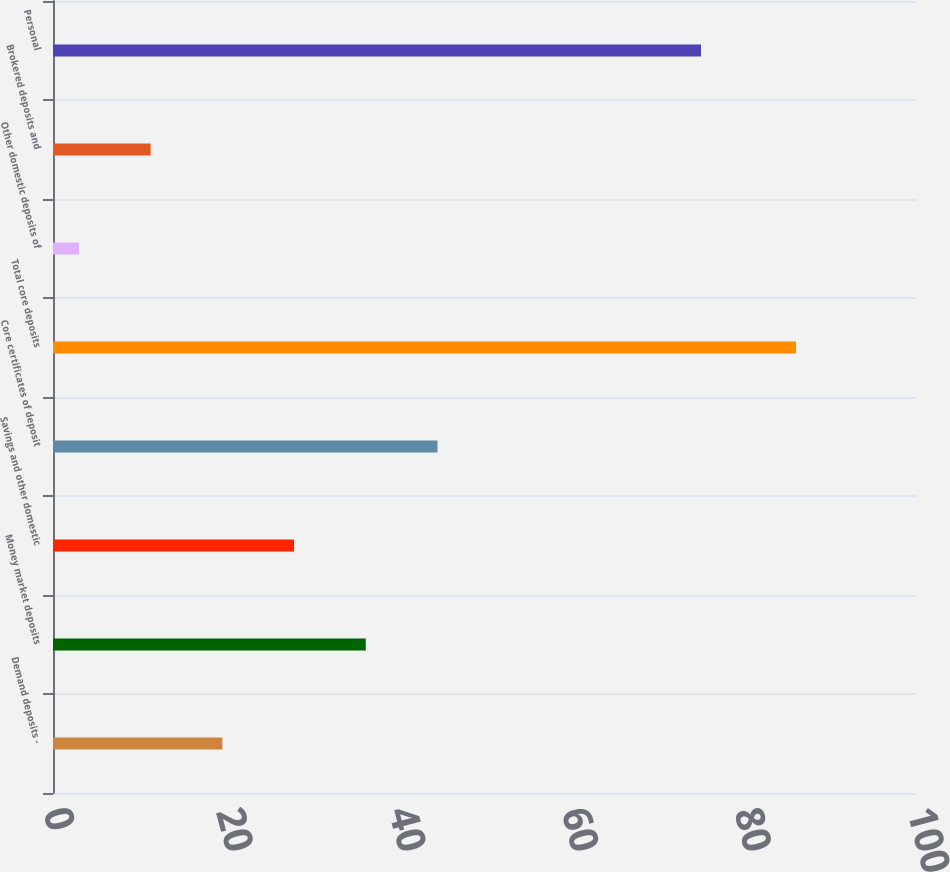<chart> <loc_0><loc_0><loc_500><loc_500><bar_chart><fcel>Demand deposits -<fcel>Money market deposits<fcel>Savings and other domestic<fcel>Core certificates of deposit<fcel>Total core deposits<fcel>Other domestic deposits of<fcel>Brokered deposits and<fcel>Personal<nl><fcel>19.6<fcel>36.2<fcel>27.9<fcel>44.5<fcel>86<fcel>3<fcel>11.3<fcel>75<nl></chart> 